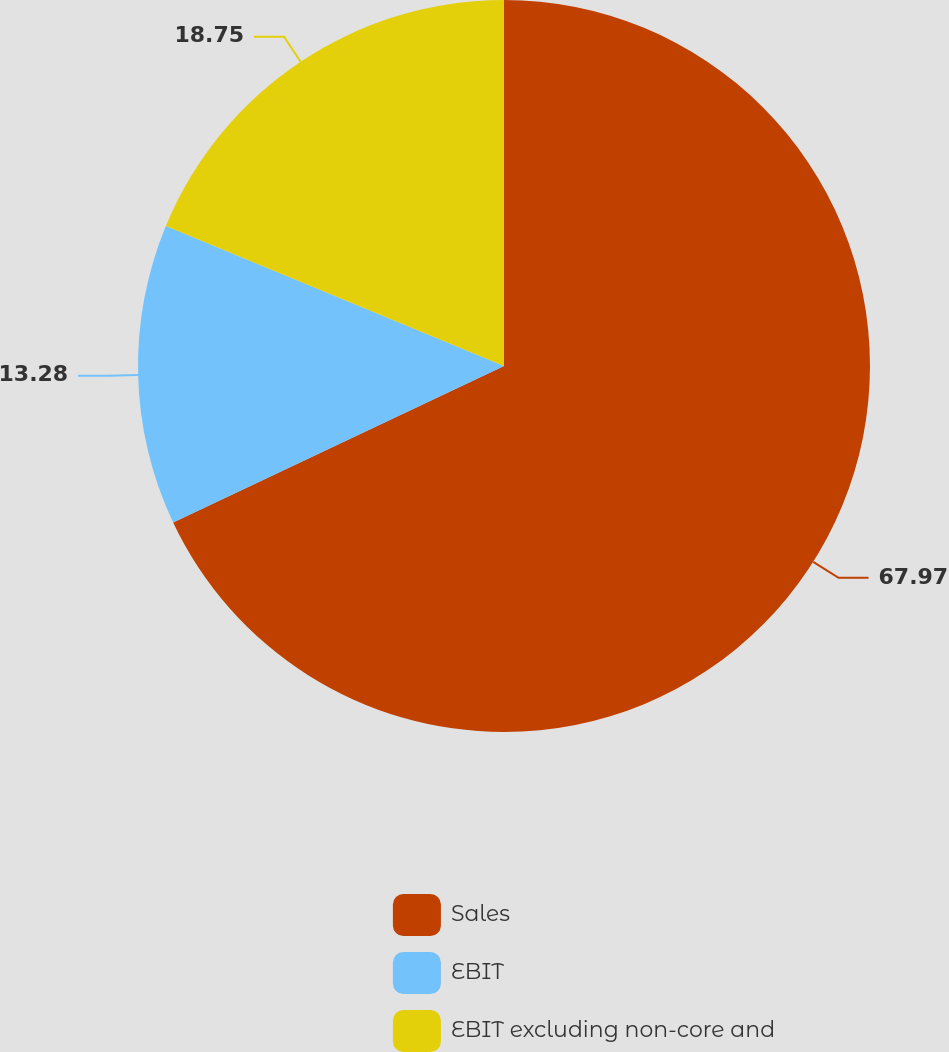<chart> <loc_0><loc_0><loc_500><loc_500><pie_chart><fcel>Sales<fcel>EBIT<fcel>EBIT excluding non-core and<nl><fcel>67.97%<fcel>13.28%<fcel>18.75%<nl></chart> 